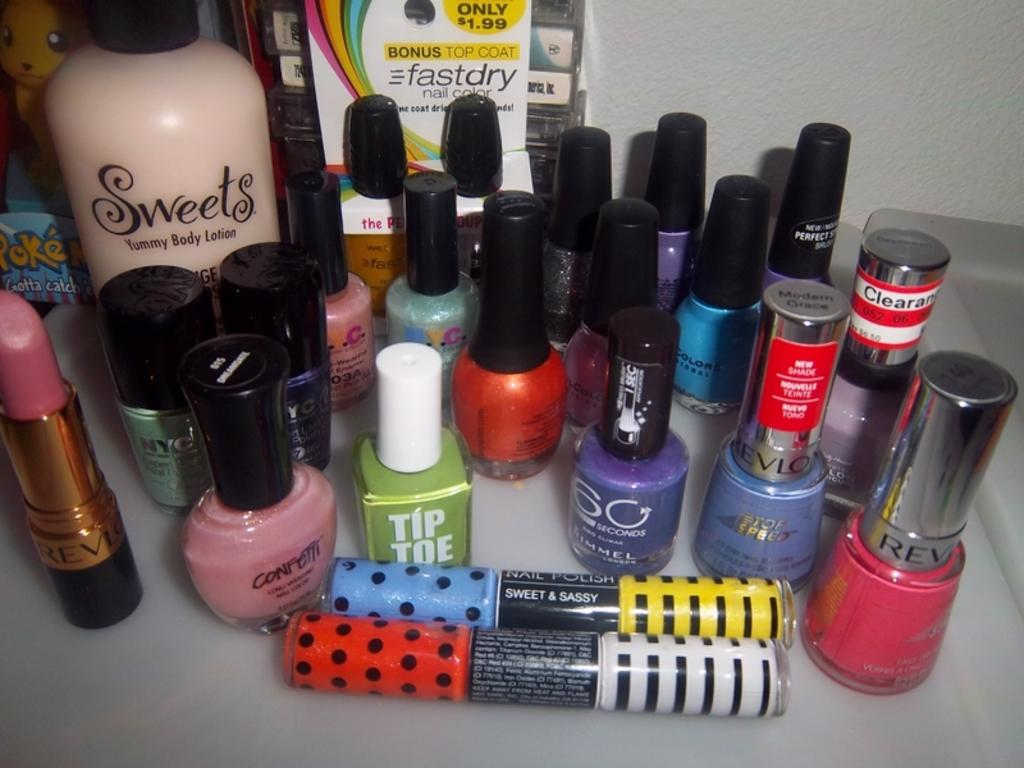Provide a one-sentence caption for the provided image. make up and nail polish from Tip Toe and Revlon on a table. 